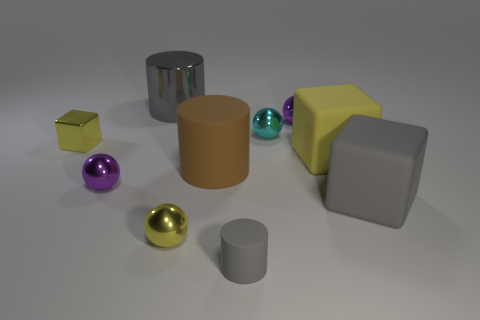Subtract all gray cylinders. How many were subtracted if there are1gray cylinders left? 1 Subtract 1 cylinders. How many cylinders are left? 2 Subtract all yellow spheres. How many spheres are left? 3 Subtract all small cyan balls. How many balls are left? 3 Subtract all green spheres. Subtract all blue blocks. How many spheres are left? 4 Add 5 yellow metallic things. How many yellow metallic things are left? 7 Add 8 matte cubes. How many matte cubes exist? 10 Subtract 0 blue cylinders. How many objects are left? 10 Subtract all cylinders. How many objects are left? 7 Subtract all small gray rubber cylinders. Subtract all cylinders. How many objects are left? 6 